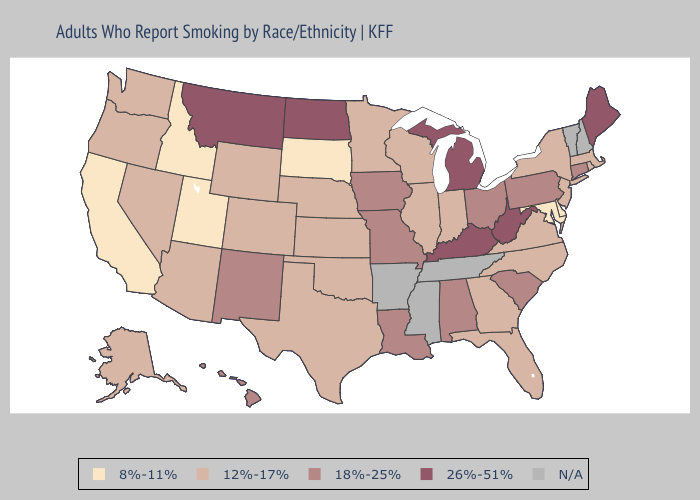Which states have the highest value in the USA?
Give a very brief answer. Kentucky, Maine, Michigan, Montana, North Dakota, West Virginia. Name the states that have a value in the range 26%-51%?
Write a very short answer. Kentucky, Maine, Michigan, Montana, North Dakota, West Virginia. What is the highest value in the South ?
Answer briefly. 26%-51%. Name the states that have a value in the range 26%-51%?
Keep it brief. Kentucky, Maine, Michigan, Montana, North Dakota, West Virginia. Among the states that border Virginia , which have the highest value?
Be succinct. Kentucky, West Virginia. What is the lowest value in states that border Oklahoma?
Write a very short answer. 12%-17%. Which states have the highest value in the USA?
Concise answer only. Kentucky, Maine, Michigan, Montana, North Dakota, West Virginia. What is the value of Rhode Island?
Be succinct. 12%-17%. Does the map have missing data?
Answer briefly. Yes. Is the legend a continuous bar?
Quick response, please. No. What is the lowest value in the USA?
Concise answer only. 8%-11%. 